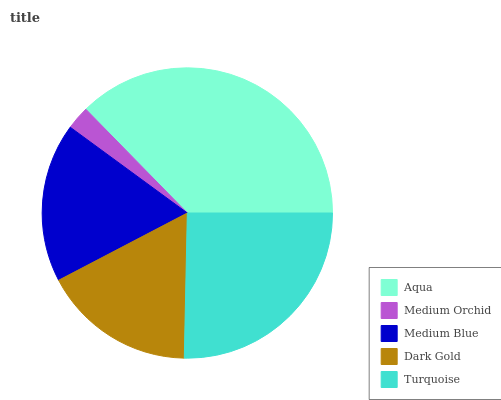Is Medium Orchid the minimum?
Answer yes or no. Yes. Is Aqua the maximum?
Answer yes or no. Yes. Is Medium Blue the minimum?
Answer yes or no. No. Is Medium Blue the maximum?
Answer yes or no. No. Is Medium Blue greater than Medium Orchid?
Answer yes or no. Yes. Is Medium Orchid less than Medium Blue?
Answer yes or no. Yes. Is Medium Orchid greater than Medium Blue?
Answer yes or no. No. Is Medium Blue less than Medium Orchid?
Answer yes or no. No. Is Medium Blue the high median?
Answer yes or no. Yes. Is Medium Blue the low median?
Answer yes or no. Yes. Is Aqua the high median?
Answer yes or no. No. Is Aqua the low median?
Answer yes or no. No. 